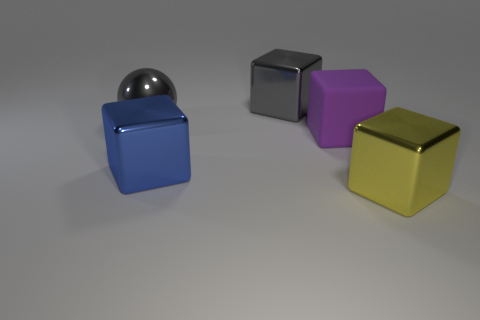What number of rubber things are big gray blocks or spheres?
Give a very brief answer. 0. There is a cube behind the big thing left of the large blue block; what color is it?
Ensure brevity in your answer.  Gray. Do the blue thing and the block behind the big purple matte block have the same material?
Offer a terse response. Yes. The big shiny block behind the big metallic block that is left of the metal block behind the large metal sphere is what color?
Provide a short and direct response. Gray. Are there more big gray things than large blue rubber things?
Provide a short and direct response. Yes. How many big metal blocks are both on the left side of the purple matte cube and in front of the rubber block?
Give a very brief answer. 1. There is a block behind the rubber object; how many gray balls are to the right of it?
Your answer should be very brief. 0. Do the gray shiny thing that is in front of the gray cube and the cube that is behind the gray ball have the same size?
Offer a very short reply. Yes. What number of large gray metallic cubes are there?
Make the answer very short. 1. What number of large gray spheres have the same material as the blue block?
Ensure brevity in your answer.  1. 